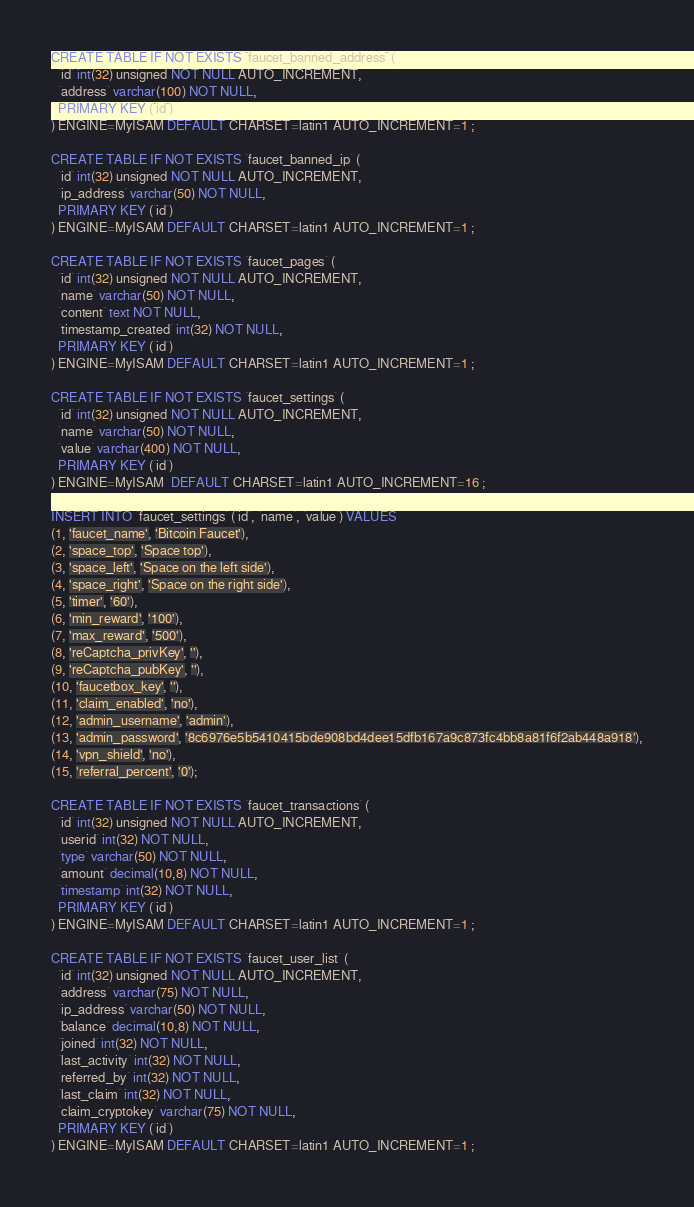Convert code to text. <code><loc_0><loc_0><loc_500><loc_500><_SQL_>CREATE TABLE IF NOT EXISTS `faucet_banned_address` (
  `id` int(32) unsigned NOT NULL AUTO_INCREMENT,
  `address` varchar(100) NOT NULL,
  PRIMARY KEY (`id`)
) ENGINE=MyISAM DEFAULT CHARSET=latin1 AUTO_INCREMENT=1 ;

CREATE TABLE IF NOT EXISTS `faucet_banned_ip` (
  `id` int(32) unsigned NOT NULL AUTO_INCREMENT,
  `ip_address` varchar(50) NOT NULL,
  PRIMARY KEY (`id`)
) ENGINE=MyISAM DEFAULT CHARSET=latin1 AUTO_INCREMENT=1 ;

CREATE TABLE IF NOT EXISTS `faucet_pages` (
  `id` int(32) unsigned NOT NULL AUTO_INCREMENT,
  `name` varchar(50) NOT NULL,
  `content` text NOT NULL,
  `timestamp_created` int(32) NOT NULL,
  PRIMARY KEY (`id`)
) ENGINE=MyISAM DEFAULT CHARSET=latin1 AUTO_INCREMENT=1 ;

CREATE TABLE IF NOT EXISTS `faucet_settings` (
  `id` int(32) unsigned NOT NULL AUTO_INCREMENT,
  `name` varchar(50) NOT NULL,
  `value` varchar(400) NOT NULL,
  PRIMARY KEY (`id`)
) ENGINE=MyISAM  DEFAULT CHARSET=latin1 AUTO_INCREMENT=16 ;

INSERT INTO `faucet_settings` (`id`, `name`, `value`) VALUES
(1, 'faucet_name', 'Bitcoin Faucet'),
(2, 'space_top', 'Space top'),
(3, 'space_left', 'Space on the left side'),
(4, 'space_right', 'Space on the right side'),
(5, 'timer', '60'),
(6, 'min_reward', '100'),
(7, 'max_reward', '500'),
(8, 'reCaptcha_privKey', ''),
(9, 'reCaptcha_pubKey', ''),
(10, 'faucetbox_key', ''),
(11, 'claim_enabled', 'no'),
(12, 'admin_username', 'admin'),
(13, 'admin_password', '8c6976e5b5410415bde908bd4dee15dfb167a9c873fc4bb8a81f6f2ab448a918'),
(14, 'vpn_shield', 'no'),
(15, 'referral_percent', '0');

CREATE TABLE IF NOT EXISTS `faucet_transactions` (
  `id` int(32) unsigned NOT NULL AUTO_INCREMENT,
  `userid` int(32) NOT NULL,
  `type` varchar(50) NOT NULL,
  `amount` decimal(10,8) NOT NULL,
  `timestamp` int(32) NOT NULL,
  PRIMARY KEY (`id`)
) ENGINE=MyISAM DEFAULT CHARSET=latin1 AUTO_INCREMENT=1 ;

CREATE TABLE IF NOT EXISTS `faucet_user_list` (
  `id` int(32) unsigned NOT NULL AUTO_INCREMENT,
  `address` varchar(75) NOT NULL,
  `ip_address` varchar(50) NOT NULL,
  `balance` decimal(10,8) NOT NULL,
  `joined` int(32) NOT NULL,
  `last_activity` int(32) NOT NULL,
  `referred_by` int(32) NOT NULL,
  `last_claim` int(32) NOT NULL,
  `claim_cryptokey` varchar(75) NOT NULL,
  PRIMARY KEY (`id`)
) ENGINE=MyISAM DEFAULT CHARSET=latin1 AUTO_INCREMENT=1 ;</code> 